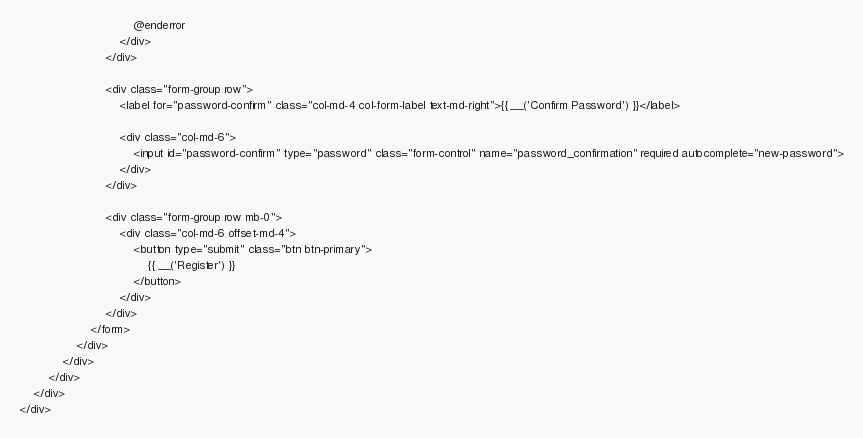Convert code to text. <code><loc_0><loc_0><loc_500><loc_500><_PHP_>                                @enderror
                            </div>
                        </div>

                        <div class="form-group row">
                            <label for="password-confirm" class="col-md-4 col-form-label text-md-right">{{ __('Confirm Password') }}</label>

                            <div class="col-md-6">
                                <input id="password-confirm" type="password" class="form-control" name="password_confirmation" required autocomplete="new-password">
                            </div>
                        </div>

                        <div class="form-group row mb-0">
                            <div class="col-md-6 offset-md-4">
                                <button type="submit" class="btn btn-primary">
                                    {{ __('Register') }}
                                </button>
                            </div>
                        </div>
                    </form>
                </div>
            </div>
        </div>
    </div>
</div>

</code> 